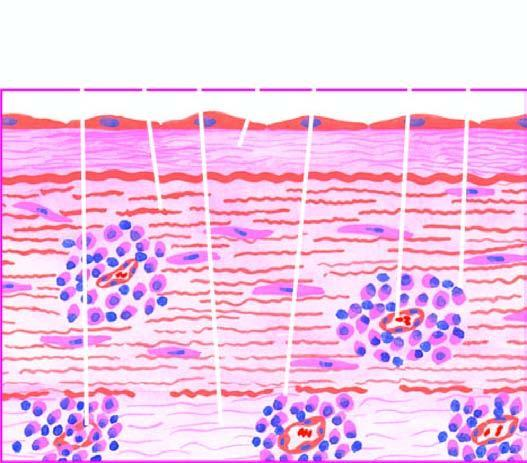what is there in the media and adventitia?
Answer the question using a single word or phrase. Endarteritis and periarteritis of the vasa vasorum 